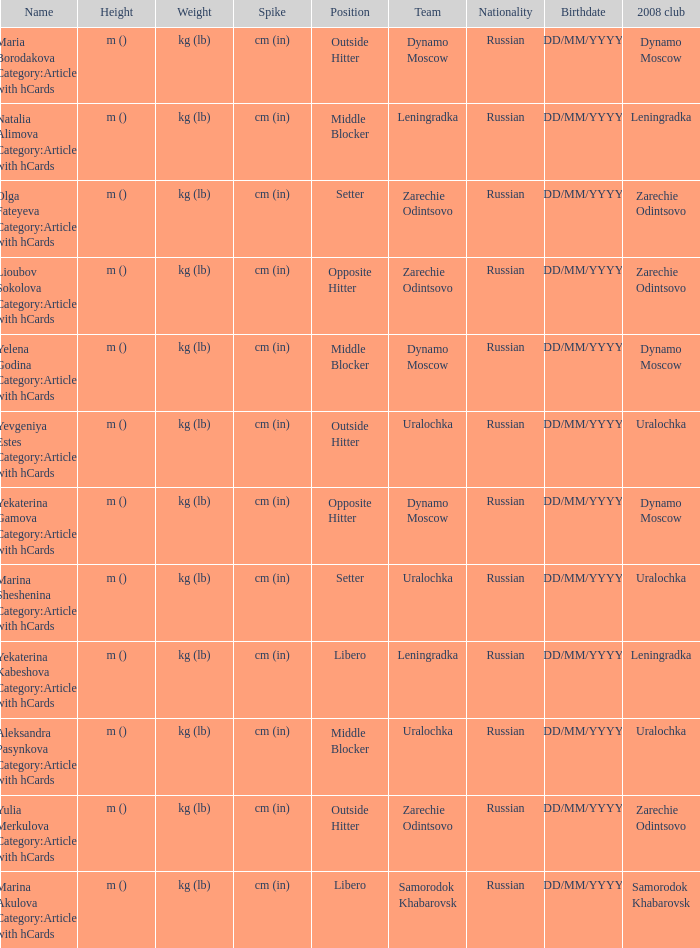What is the name when the 2008 club is uralochka? Yevgeniya Estes Category:Articles with hCards, Marina Sheshenina Category:Articles with hCards, Aleksandra Pasynkova Category:Articles with hCards. 